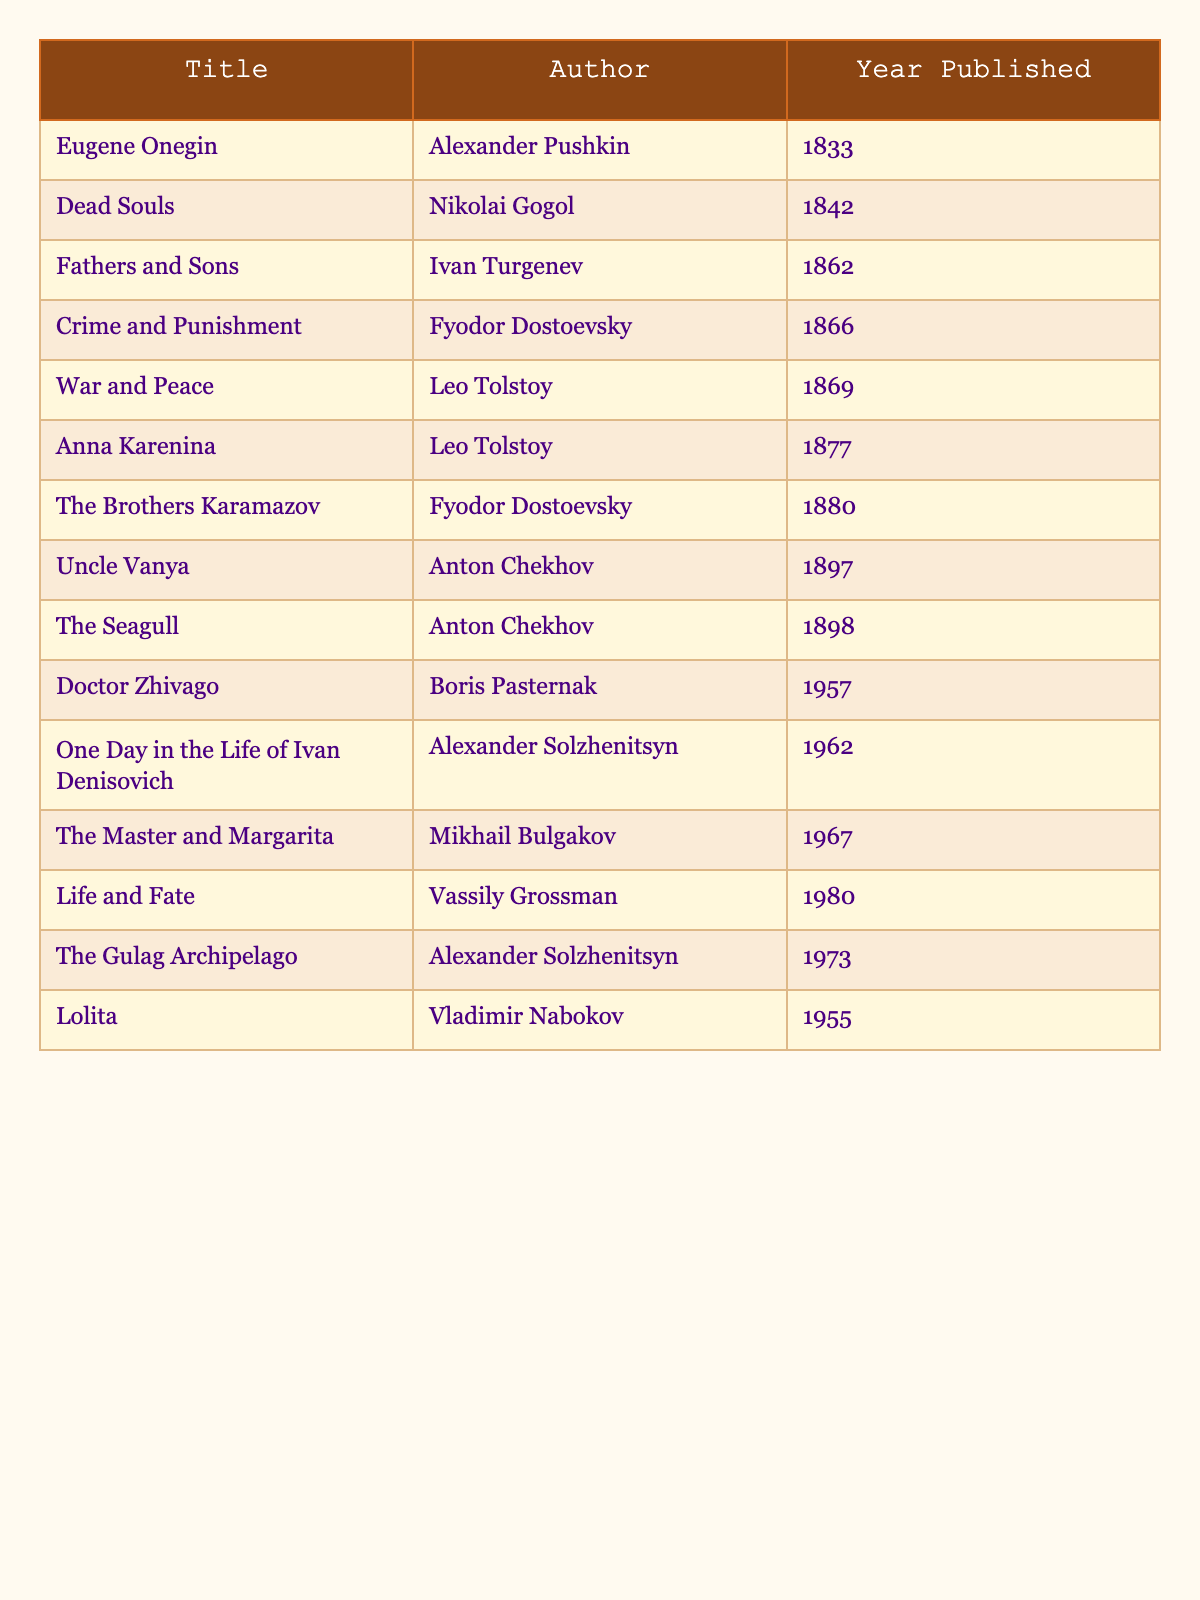What is the title of the work published in 1866? The table lists the works along with their publication years, and we can find the work published in 1866 by scanning down the Year Published column. The title corresponding to 1866 is "Crime and Punishment."
Answer: Crime and Punishment Which author wrote "War and Peace"? By looking at the title "War and Peace" in the table, we can trace it to its respective author in the Author column. The author of "War and Peace" is Leo Tolstoy.
Answer: Leo Tolstoy How many works were published before 1900? We can count the number of works listed in the table and check their publication years. The years before 1900 are for "Eugene Onegin," "Dead Souls," "Fathers and Sons," "Crime and Punishment," "War and Peace," "Anna Karenina," "The Brothers Karamazov," "Uncle Vanya," and "The Seagull," which sums up to 9 works.
Answer: 9 What year was "Doctor Zhivago" published in relation to "Lolita"? "Doctor Zhivago" was published in 1957 and "Lolita" in 1955. Comparing the two years shows that "Doctor Zhivago" was published 2 years later than "Lolita."
Answer: 2 years later Which two authors had works published in the same year, 1898? Looking through the table, the year 1898 shows "The Seagull" written by Anton Chekhov. To find another work published that same year, we see there isn’t another title listed under that year, meaning Anton Chekhov is the sole author for 1898.
Answer: No other author What is the most recent publication listed in the table? We identify the highest year listed in the Year Published column. The recent publication is "Life and Fate," which was released in 1980.
Answer: Life and Fate How many authors have works published in the 1950s? We can look for works in the years 1955 and 1957. "Lolita" (1955) and "Doctor Zhivago" (1957) are the two works that meet this criteria, thus referring to two unique authors: Vladimir Nabokov and Boris Pasternak.
Answer: 2 authors Which author has the most works listed in the table? Scanning through the authors listed, we note Alexander Pushkin has 1, Nikolai Gogol has 1, Ivan Turgenev has 1, Fyodor Dostoevsky has 2, Leo Tolstoy has 2, Anton Chekhov has 2, Boris Pasternak has 1, Alexander Solzhenitsyn has 2, Mikhail Bulgakov has 1, Vassily Grossman has 1, and Vladimir Nabokov has 1. The authors with the highest number of works are Dostoevsky, Tolstoy, Chekhov, and Solzhenitsyn, each with 2.
Answer: 4 authors (Dostoevsky, Tolstoy, Chekhov, Solzhenitsyn) What publication year falls in the middle of the chronological list? First, we sort the publication years: 1833, 1842, 1862, 1866, 1869, 1877, 1880, 1897, 1898, 1955, 1957, 1962, 1967, 1973, 1980. There are 15 total publications; therefore, the median falls between the 7th (1880) and 8th (1897) works, which gives us: (1880 + 1897) / 2 = 1888.5.
Answer: 1888.5 What percentage of the works listed were published after 1950? We count the total works (15) and the number published after 1950 (6: 1955, 1957, 1962, 1967, 1973, and 1980). To calculate the percentage, we do (6/15) * 100 = 40%.
Answer: 40% 